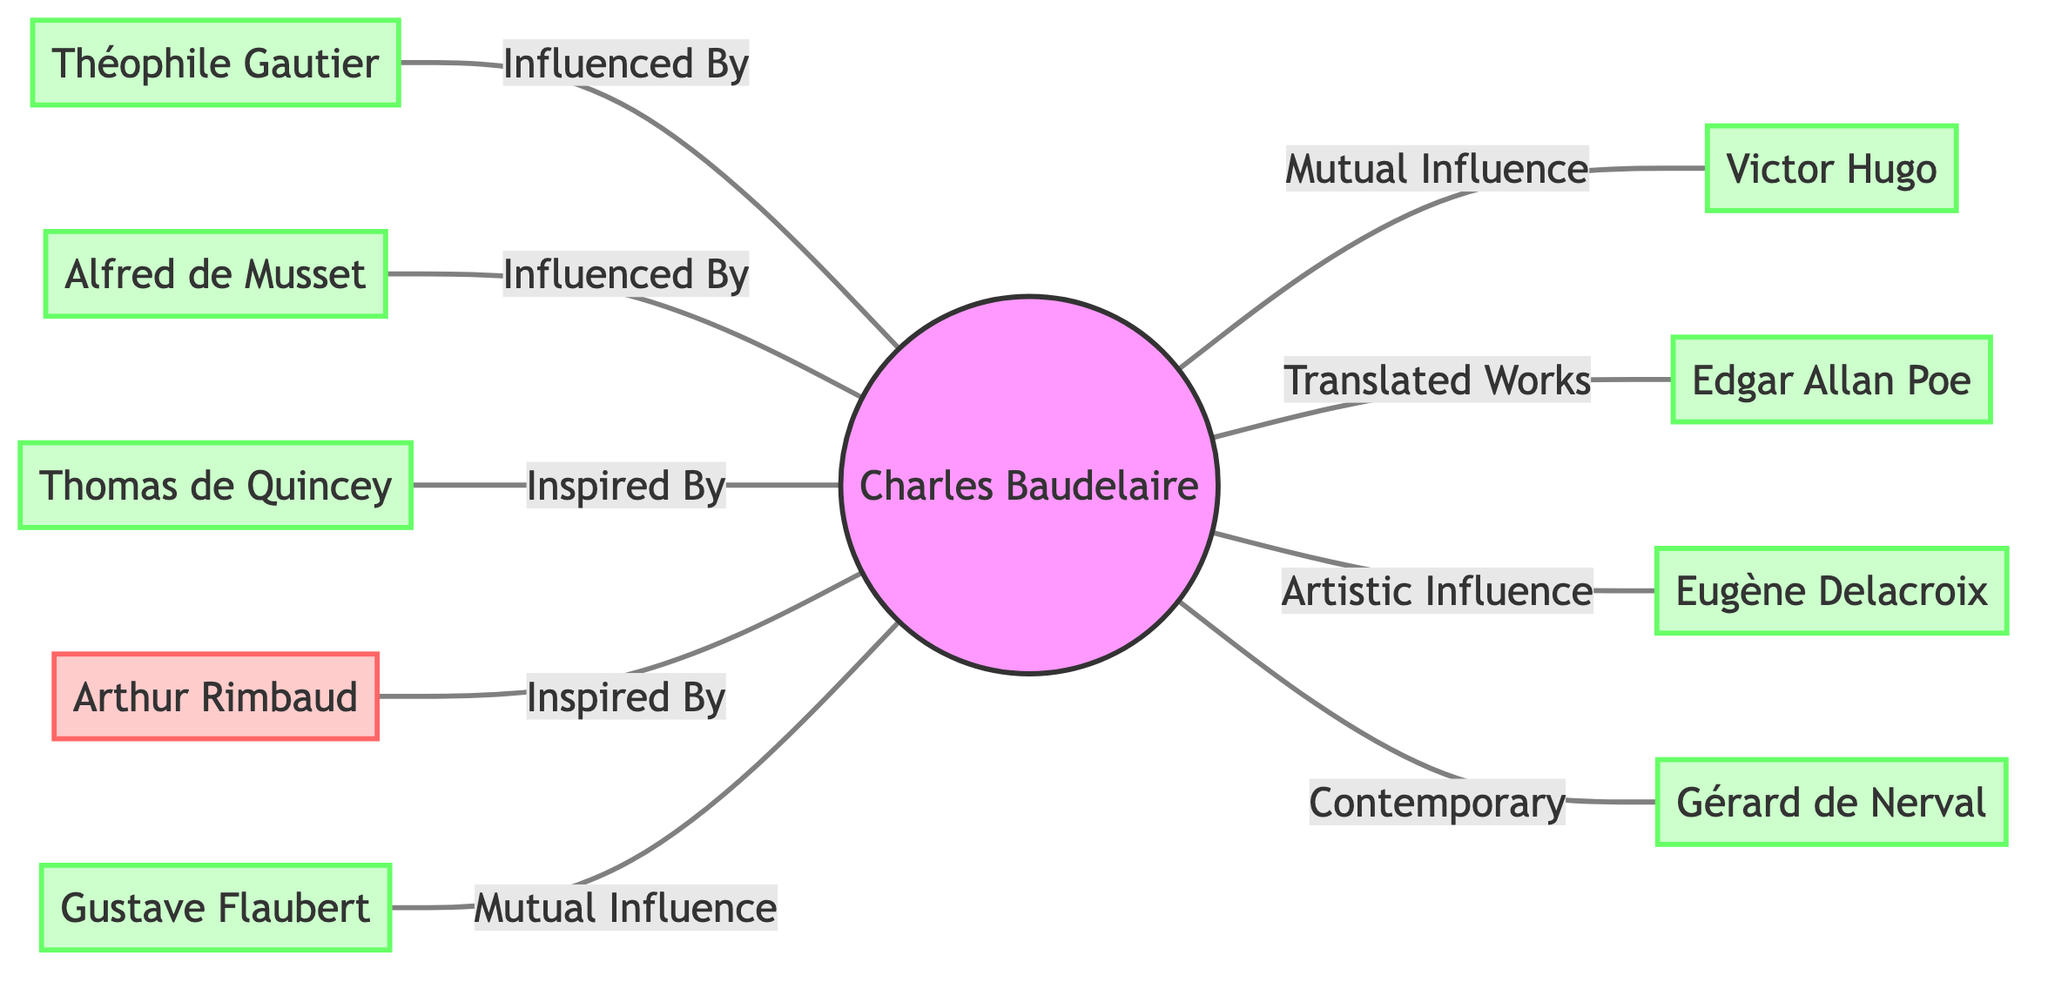What is the number of authors directly influencing Baudelaire? In the diagram, Baudelaire is connected to six authors (Hugo, Gautier, Poe, Delacroix, Musset, de Quincey, Nerval, and Flaubert) as influencers. Count the edges connecting these authors to Baudelaire, which gives us the total.
Answer: 8 Who is influenced by Baudelaire among the authors listed? In looking at the diagram, Rimbaud and Gautier are shown as being influenced or inspired by Baudelaire. Checking the connections reveals that Gautier has a one-way influence from Baudelaire, and Rimbaud is also connected as inspired by him.
Answer: Rimbaud and Gautier What is the relationship between Baudelaire and Hugo? The relationship shown in the diagram indicates "Mutual Influence" between Baudelaire and Hugo. This means that both authors have impacted each other's works in some significant ways, thus establishing a reciprocal connection.
Answer: Mutual Influence Which author is connected to Baudelaire with "Artistic Influence"? To determine this, we examine the specific connections. The label "Artistic Influence" in the diagram directly points to the connection from Baudelaire to Delacroix, suggesting a significant artistic relationship between the two.
Answer: Delacroix How many authors are depicted in total in the diagram? To find the total, we count all unique author nodes present in the diagram: Baudelaire, Hugo, Gautier, Poe, Delacroix, Musset, de Quincey, Nerval, Rimbaud, and Flaubert. Adding these gives us the total number of authors shown in the network diagram.
Answer: 10 Which author is influenced by Baudelaire but is also a contemporary? By checking the relationships in the diagram, we see that Nerval is noted as a "Contemporary" of Baudelaire, and the label also indicates that there is a connection, but the specific relationship shows influence as well.
Answer: Nerval Which author has the strongest direct influence on Baudelaire? The flowchart indicates that Hugo has a "Mutual Influence" connection with Baudelaire, while others have varied one-way influences. This mutual influence suggests a deeper and more impactful relationship than the others, denoting Hugo as the strongest direct influence.
Answer: Hugo Which two authors have a direct influence connection represented on the diagram that does not involve Baudelaire? To answer this, we need to examine the diagram for any authors connected by lines that do not include Baudelaire. Upon analysis, we see that no such connections exist; all connections involve Baudelaire.
Answer: None 